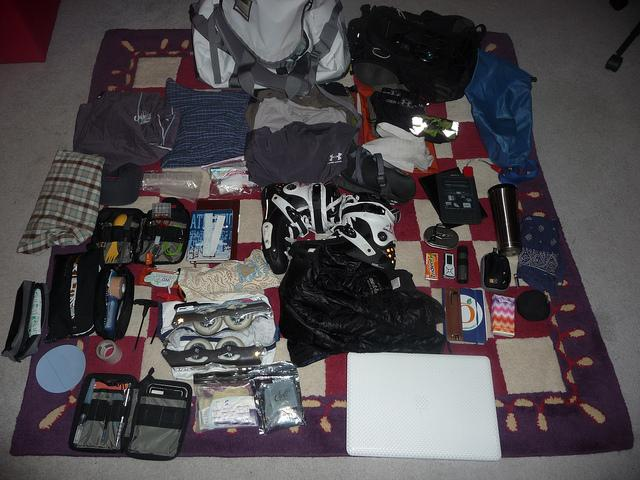Items here are laid out due to what purpose? Please explain your reasoning. packing backpack. These are all items you would need if you were going somewhere you can see in the back there is a white bag that looks like a backpack the person logically would put all of the small items in the backpack so that they are contained throughout their trip. 